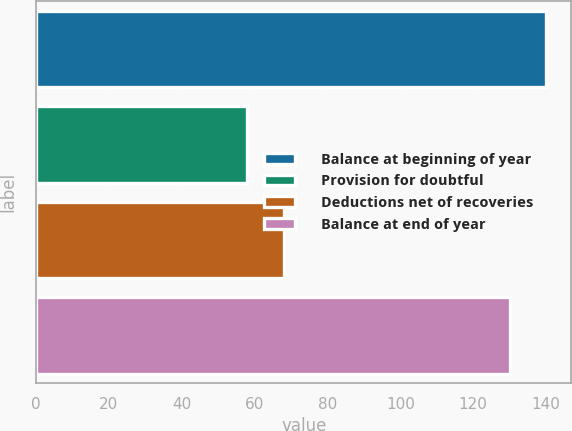Convert chart. <chart><loc_0><loc_0><loc_500><loc_500><bar_chart><fcel>Balance at beginning of year<fcel>Provision for doubtful<fcel>Deductions net of recoveries<fcel>Balance at end of year<nl><fcel>140<fcel>58<fcel>68<fcel>130<nl></chart> 